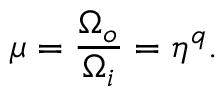Convert formula to latex. <formula><loc_0><loc_0><loc_500><loc_500>\mu = \frac { \Omega _ { o } } { \Omega _ { i } } = \eta ^ { q } .</formula> 